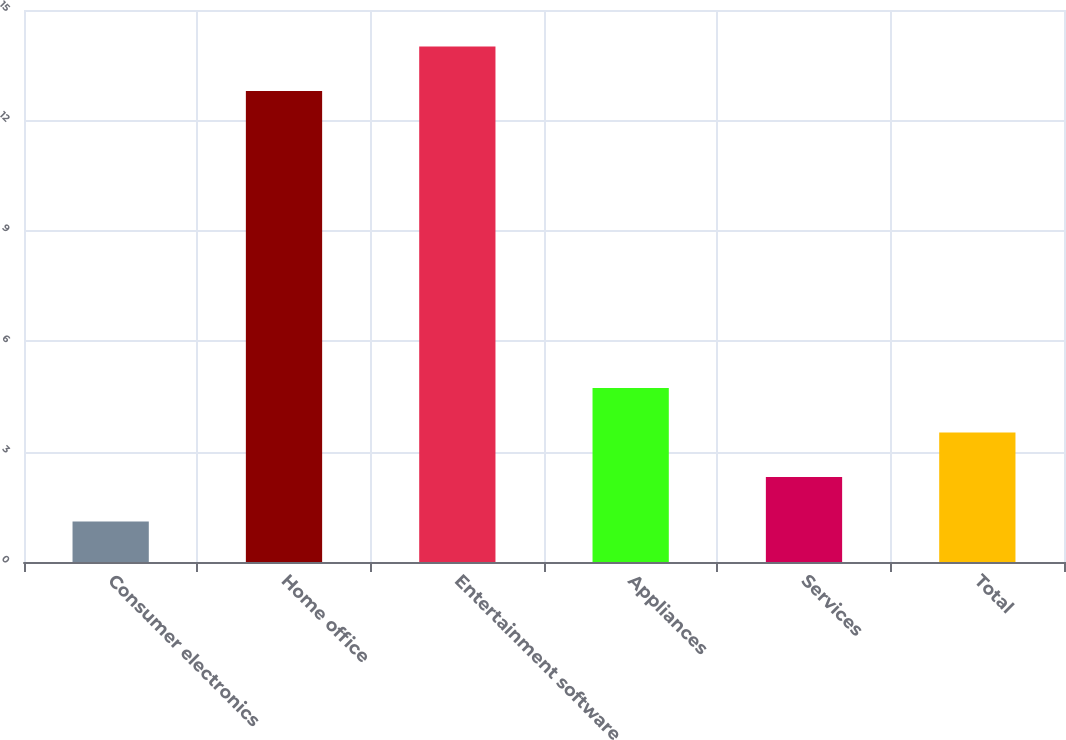Convert chart. <chart><loc_0><loc_0><loc_500><loc_500><bar_chart><fcel>Consumer electronics<fcel>Home office<fcel>Entertainment software<fcel>Appliances<fcel>Services<fcel>Total<nl><fcel>1.1<fcel>12.8<fcel>14.01<fcel>4.73<fcel>2.31<fcel>3.52<nl></chart> 